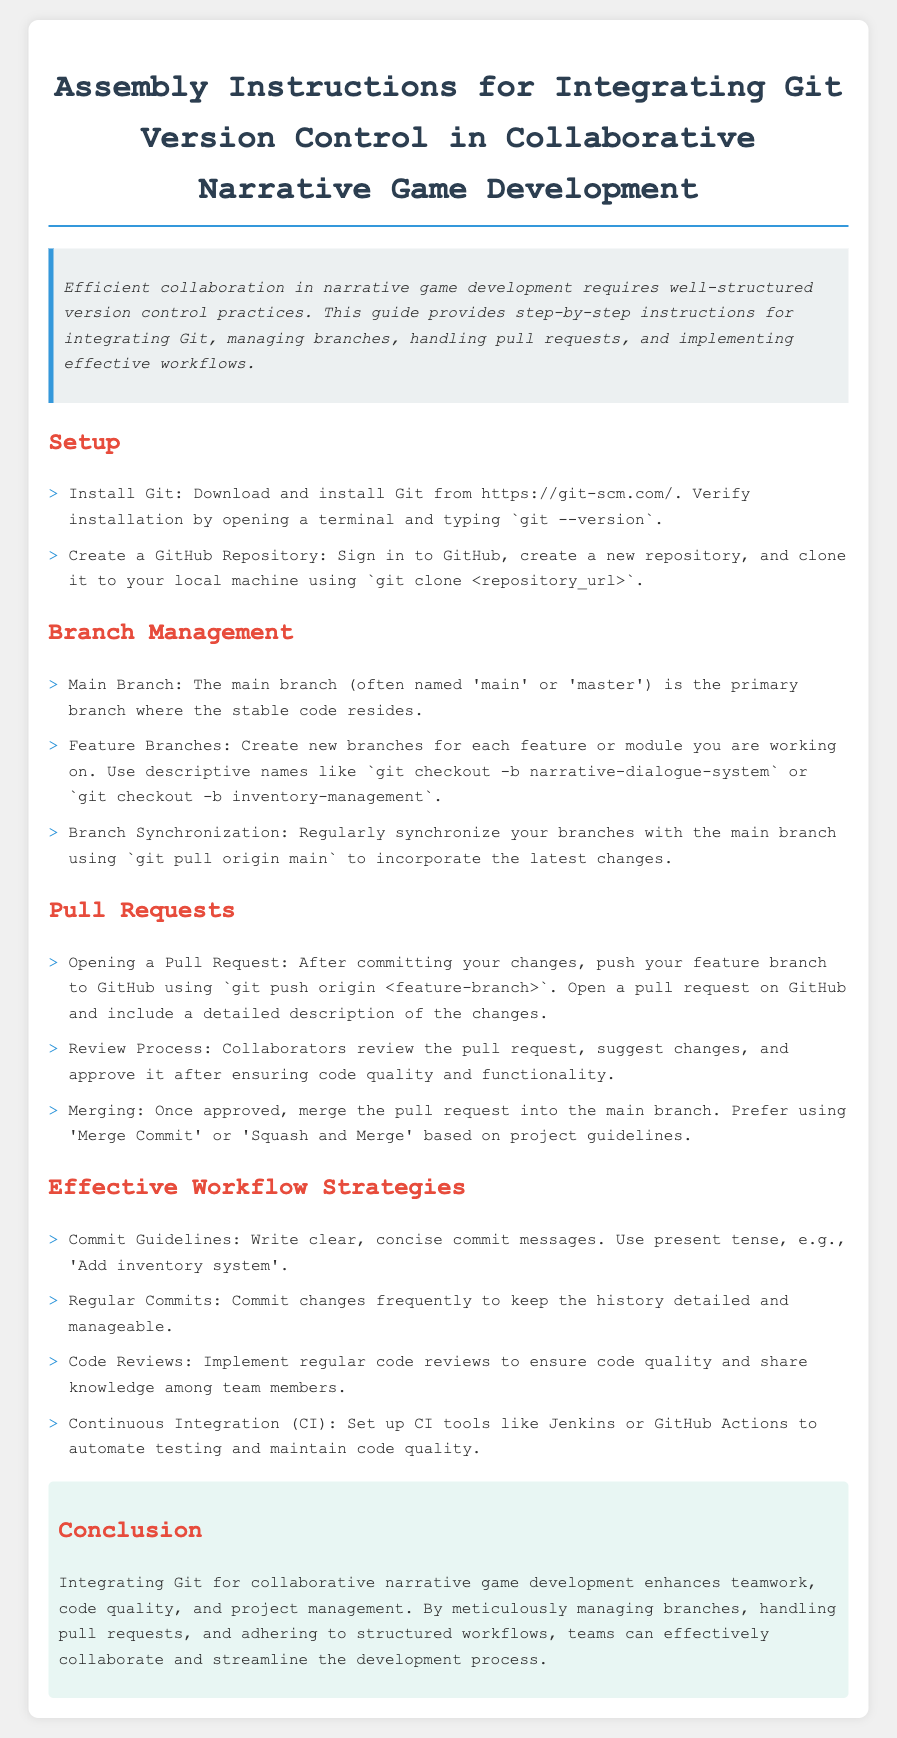what is the title of the document? The title is stated at the top of the document, summarizing the content about Git integration for game development.
Answer: Assembly Instructions for Integrating Git Version Control in Collaborative Narrative Game Development how do you verify Git installation? The document specifies a command to enter in the terminal to confirm that Git is installed correctly.
Answer: git --version what is the purpose of feature branches? The document explains that feature branches are created to work on individual features or modules separately.
Answer: Create new branches for each feature or module what should you include in a pull request description? The document indicates that a pull request description should detail the changes made in the feature branch.
Answer: A detailed description of the changes what is one example of a commit guideline mentioned? The document emphasizes writing clear commit messages using the present tense to inform others about changes.
Answer: Write clear, concise commit messages how frequently should changes be committed according to effective workflow strategies? The document discusses the importance of committing changes often to maintain a manageable history.
Answer: Frequently what tools can be set up for continuous integration? The document mentions specific tools that can automate testing and help maintain code quality.
Answer: Jenkins or GitHub Actions what branch type contains the stable code? The document specifically refers to the main branch as the location where stable code is kept.
Answer: Main branch what are the two merge strategies mentioned for pull requests? The document states preferences for merging based on project guidelines, highlighting specific strategies.
Answer: Merge Commit or Squash and Merge 